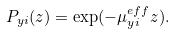<formula> <loc_0><loc_0><loc_500><loc_500>P _ { y i } ( z ) = \exp ( - \mu _ { y i } ^ { e f f } z ) .</formula> 